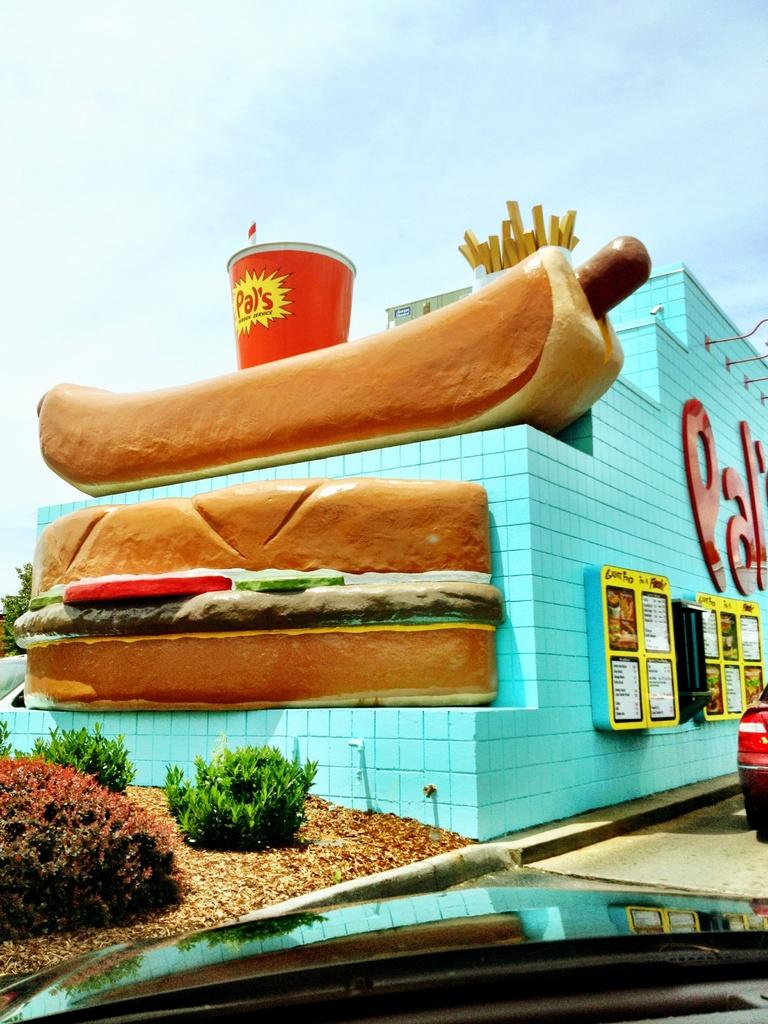What type of structure can be seen in the image? There is a building in the image. What part of the natural environment is visible in the image? The sky, trees, and bushes are visible in the image. What is the condition of the ground in the image? Shredded leaves are visible in the image, suggesting that the ground is covered with leaves. What type of pathway is present in the image? There is a road in the image. What type of signage is present in the image? Information boards are present in the image. What type of transportation is visible in the image? Motor vehicles are visible in the image. Can you hear the sound of the eye in the image? There is no eye present in the image, and therefore no sound can be heard from it. 